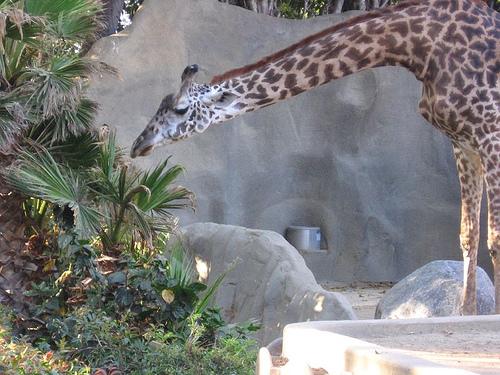What type of plant is the giraffe eating?
Give a very brief answer. Fern. Is this giraffe in its natural habitat?
Quick response, please. No. What is this animal bending down for?
Concise answer only. Food. 